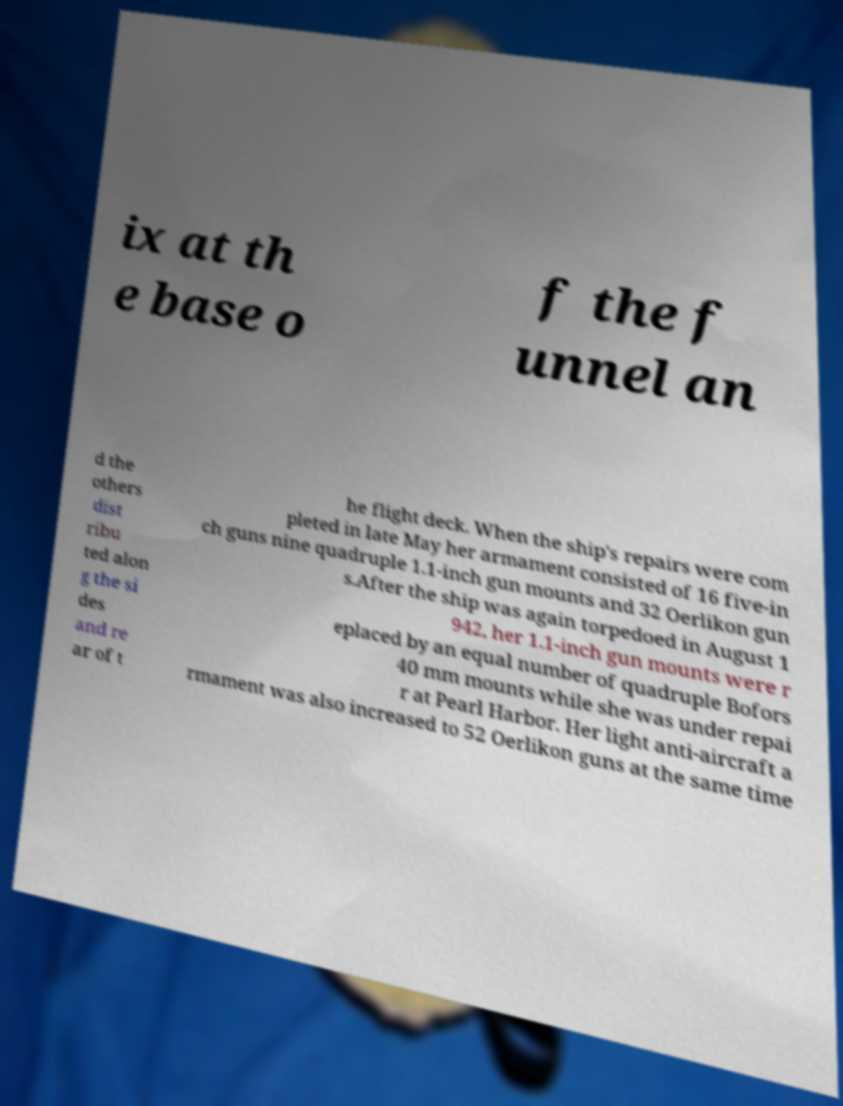Can you accurately transcribe the text from the provided image for me? ix at th e base o f the f unnel an d the others dist ribu ted alon g the si des and re ar of t he flight deck. When the ship's repairs were com pleted in late May her armament consisted of 16 five-in ch guns nine quadruple 1.1-inch gun mounts and 32 Oerlikon gun s.After the ship was again torpedoed in August 1 942, her 1.1-inch gun mounts were r eplaced by an equal number of quadruple Bofors 40 mm mounts while she was under repai r at Pearl Harbor. Her light anti-aircraft a rmament was also increased to 52 Oerlikon guns at the same time 